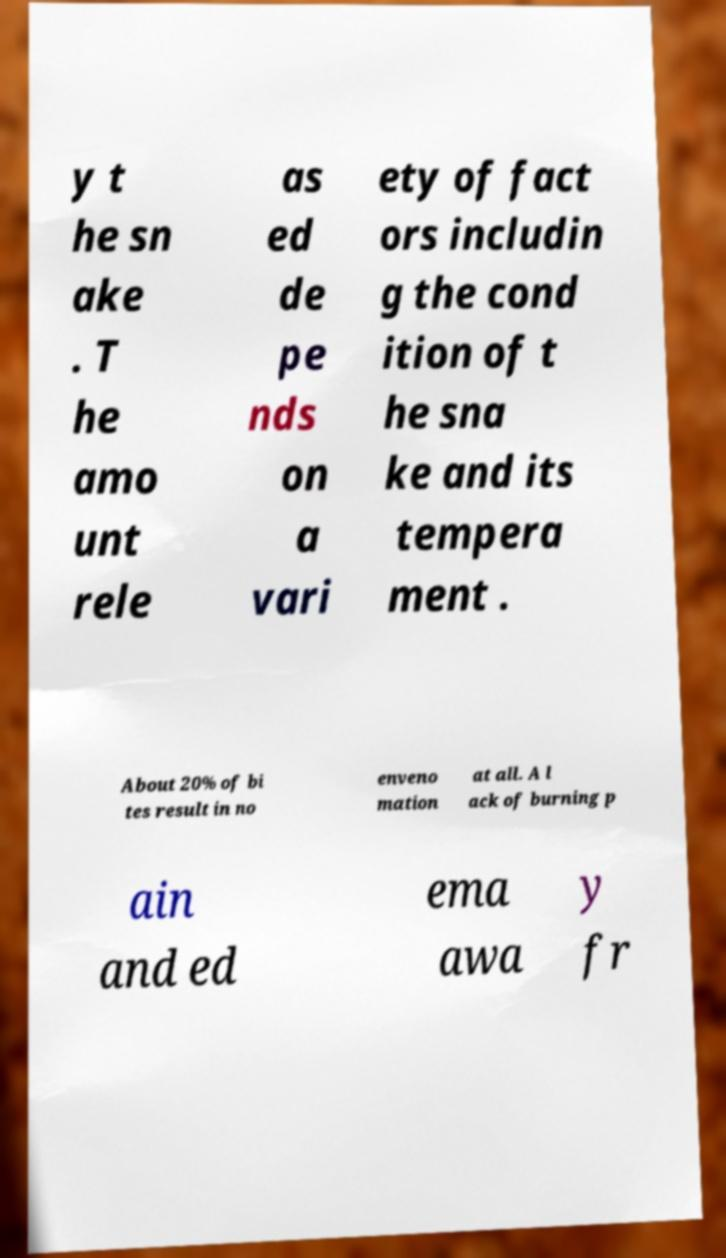For documentation purposes, I need the text within this image transcribed. Could you provide that? y t he sn ake . T he amo unt rele as ed de pe nds on a vari ety of fact ors includin g the cond ition of t he sna ke and its tempera ment . About 20% of bi tes result in no enveno mation at all. A l ack of burning p ain and ed ema awa y fr 